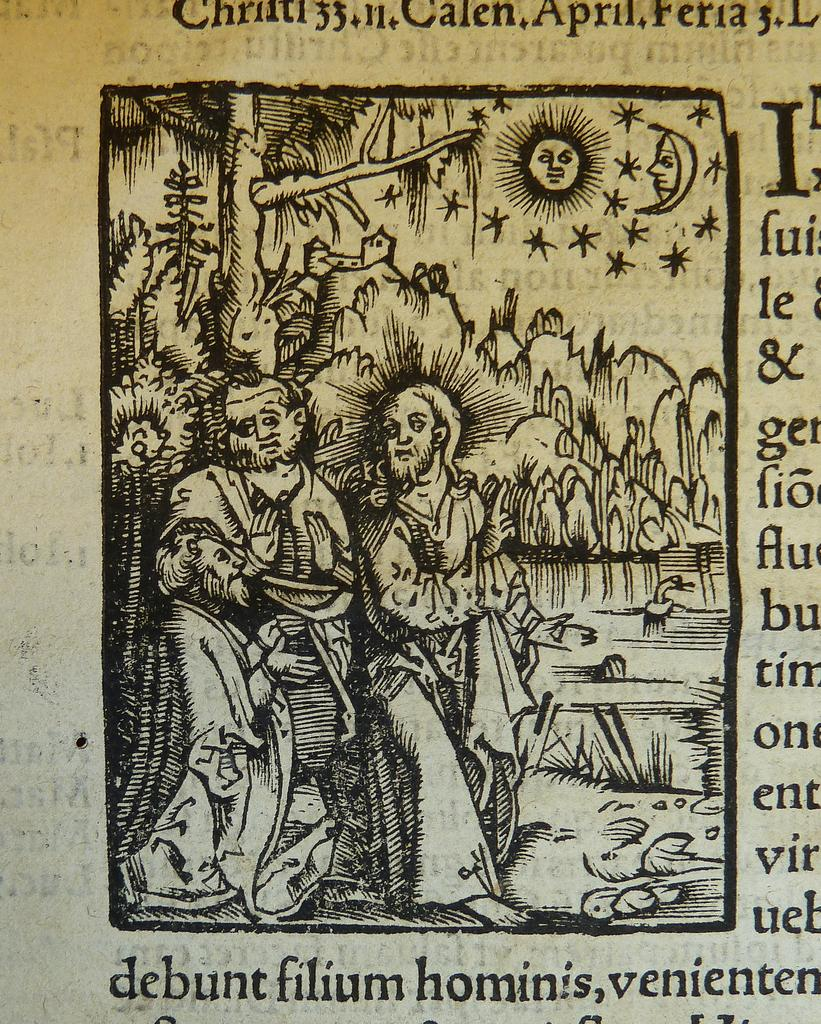What is the main subject of the image? The image is of a book. What can be seen in the center of the book? There is a painting in the center of the book. What does the painting depict? The painting depicts two men and a scenery. Where can text be found on the book? There is text at the bottom, right side, and top of the book. What type of sidewalk is visible in the image? There is no sidewalk present in the image; it is a book with a painting and text. What is the name of the person depicted in the painting? The painting depicts two men, but their names are not mentioned in the image. 